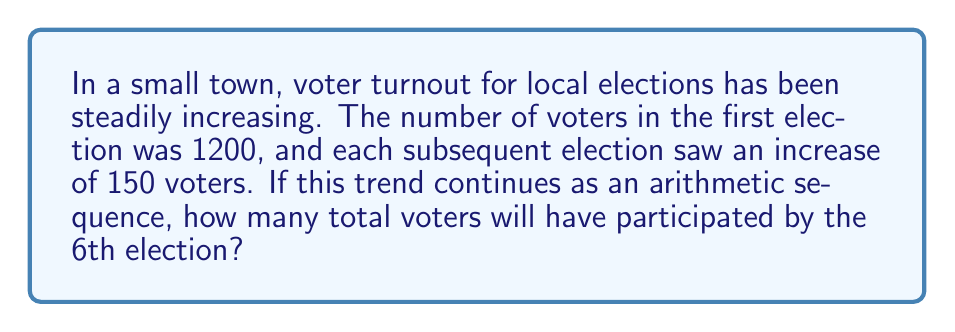Give your solution to this math problem. Let's approach this step-by-step:

1) First, we identify the components of the arithmetic sequence:
   - Initial term (a₁) = 1200 voters
   - Common difference (d) = 150 voters
   - We need to find the sum of the first 6 terms

2) The formula for the nth term of an arithmetic sequence is:
   $a_n = a_1 + (n-1)d$

3) We can calculate the number of voters for each election:
   1st election: $a_1 = 1200$
   2nd election: $a_2 = 1200 + 150 = 1350$
   3rd election: $a_3 = 1200 + 2(150) = 1500$
   4th election: $a_4 = 1200 + 3(150) = 1650$
   5th election: $a_5 = 1200 + 4(150) = 1800$
   6th election: $a_6 = 1200 + 5(150) = 1950$

4) To find the total number of voters, we need to sum these terms. We can use the formula for the sum of an arithmetic sequence:

   $S_n = \frac{n}{2}(a_1 + a_n)$

   Where $S_n$ is the sum of n terms, $a_1$ is the first term, and $a_n$ is the nth term.

5) Substituting our values:
   $S_6 = \frac{6}{2}(1200 + 1950)$
   $S_6 = 3(3150)$
   $S_6 = 9450$

Therefore, the total number of voters who will have participated by the 6th election is 9450.
Answer: 9450 voters 